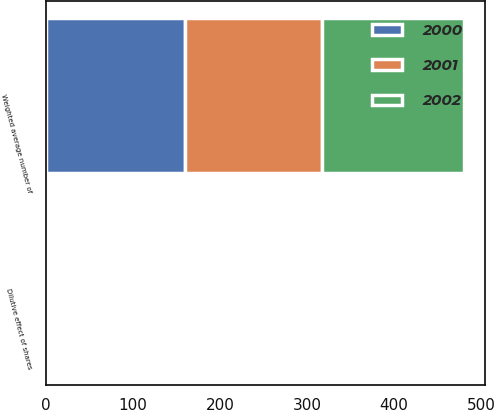<chart> <loc_0><loc_0><loc_500><loc_500><stacked_bar_chart><ecel><fcel>Weighted average number of<fcel>Dilutive effect of shares<nl><fcel>2001<fcel>157.5<fcel>3.6<nl><fcel>2000<fcel>160.2<fcel>2.6<nl><fcel>2002<fcel>163<fcel>1.3<nl></chart> 